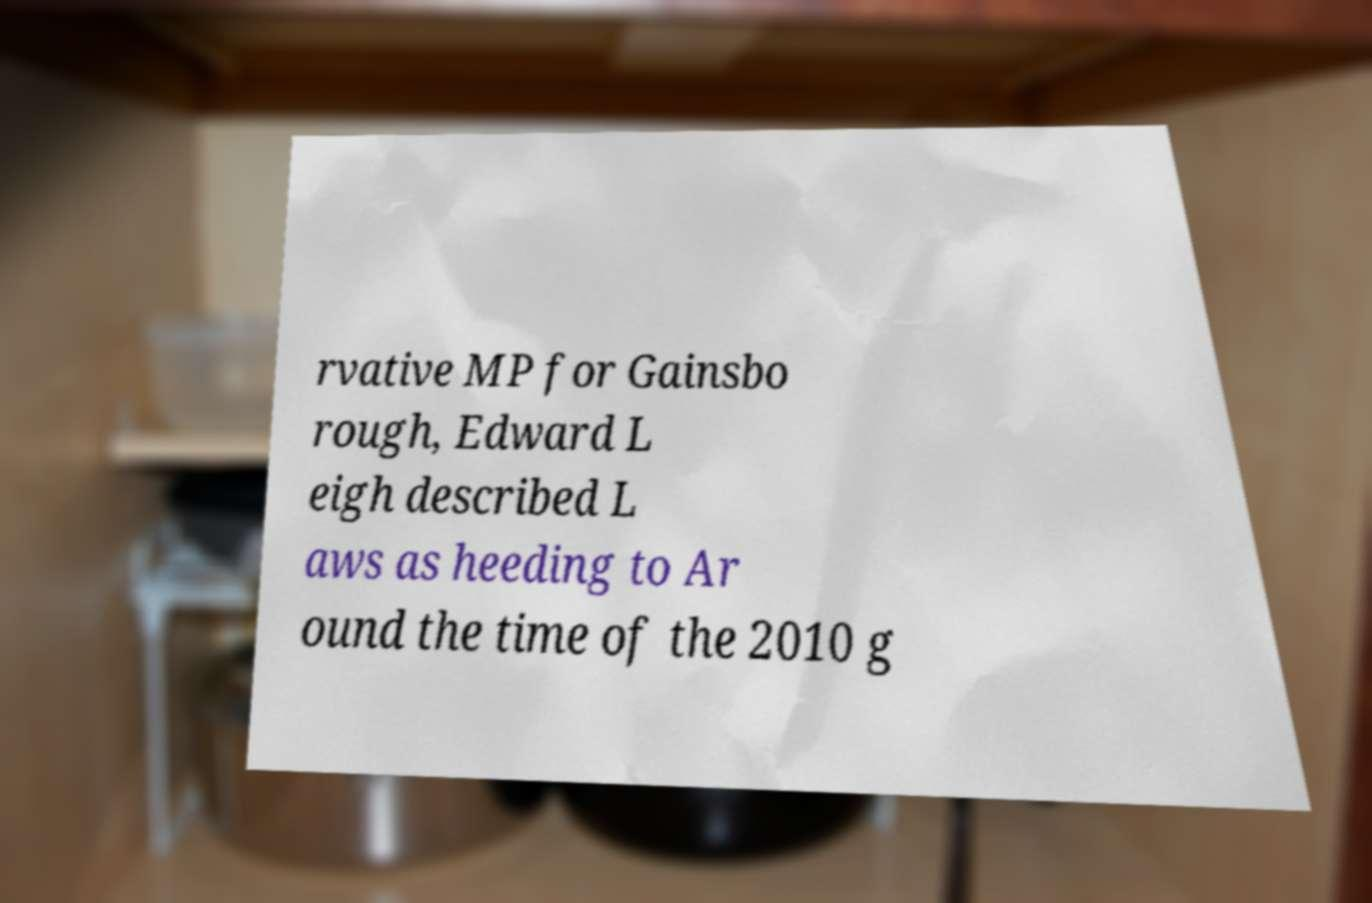I need the written content from this picture converted into text. Can you do that? rvative MP for Gainsbo rough, Edward L eigh described L aws as heeding to Ar ound the time of the 2010 g 